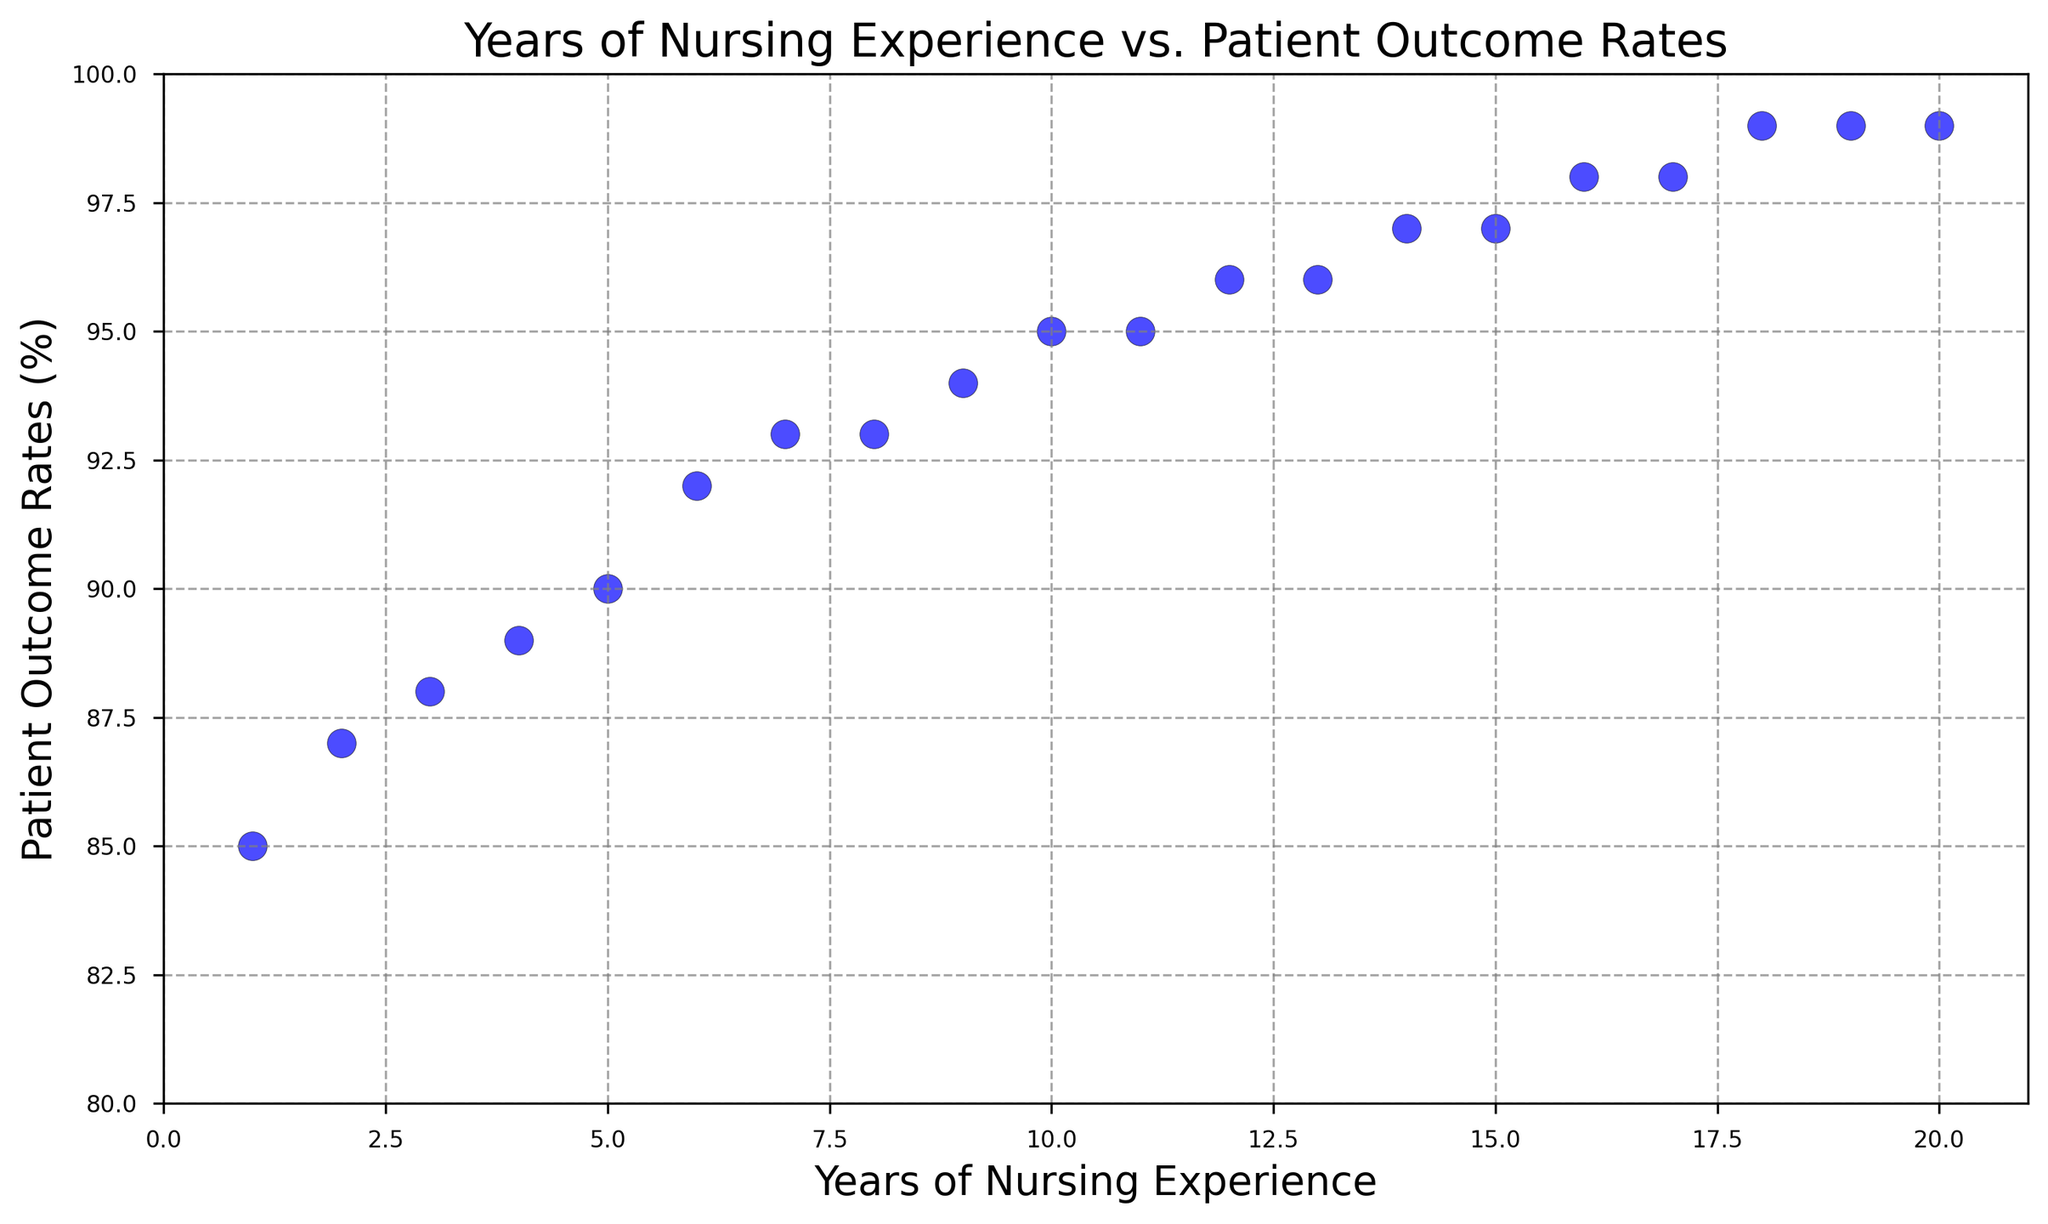What is the range of patient outcome rates shown in the figure? To find the range, subtract the smallest patient outcome rate from the largest. From the figure, the smallest patient outcome rate is 85% and the largest is 99%. So, 99 - 85 = 14.
Answer: 14 Is there a general trend in patient outcome rates as years of nursing experience increase? By visually inspecting the scatter plot, we can see that patient outcome rates tend to increase as the years of nursing experience increase. Most points lie on an upward trend.
Answer: Yes, they increase Which year of experience shows the first occurrence of a patient outcome rate of 97%? Looking at the scatter plot, we locate the point at which the patient outcome rate first reaches 97%. This occurs at 14 years of nursing experience.
Answer: 14 years Between which years of nursing experience does the patient outcome rate remain constant at 93%? Locate the points where the outcome rate is 93% on the y-axis and look at the corresponding x-axis values. These points occur at 7 and 8 years of experience.
Answer: 7 to 8 years What is the average patient outcome rate for nurses with 10 to 15 years of experience? To calculate the average, sum the rates for each year between 10 and 15 years (95, 96, 96, 97, 97, 98), then divide by the number of years (6). The sum is 579, so the average is 579 / 6 = 96.5%.
Answer: 96.5% How many years of nursing experience are associated with an outcome rate of 99%? By counting the points where the patient outcome rate is 99% on the scatter plot, these are at 18, 19, and 20 years of experience.
Answer: 3 years What is the difference in patient outcome rate between 5 years and 15 years of nursing experience? Subtract the patient outcome rate at 5 years from the rate at 15 years. The rate at 5 years is 90% and at 15 years is 97%. So 97 - 90 = 7%.
Answer: 7% At which year of nursing experience does the patient outcome rate reach 95% for the first time? Find the first point where the patient outcome rate is 95% on the y-axis, which occurs at 10 years of nursing experience.
Answer: 10 years How does the patient outcome rate change between 12 and 13 years of nursing experience? Look at the outcome rates at 12 and 13 years. Both are at 96%. Thus, there is no change between these years.
Answer: It remains the same What is the median patient outcome rate for the entire dataset? Arrange all patient outcome rates in ascending order and find the middle value. The sorted rates: 85, 87, 88, 89, 90, 92, 93, 93, 94, 95, 95, 96, 96, 97, 97, 98, 98, 99, 99, 99. The median is the average of the 10th and 11th values, (95 + 95) / 2 = 95%.
Answer: 95% 